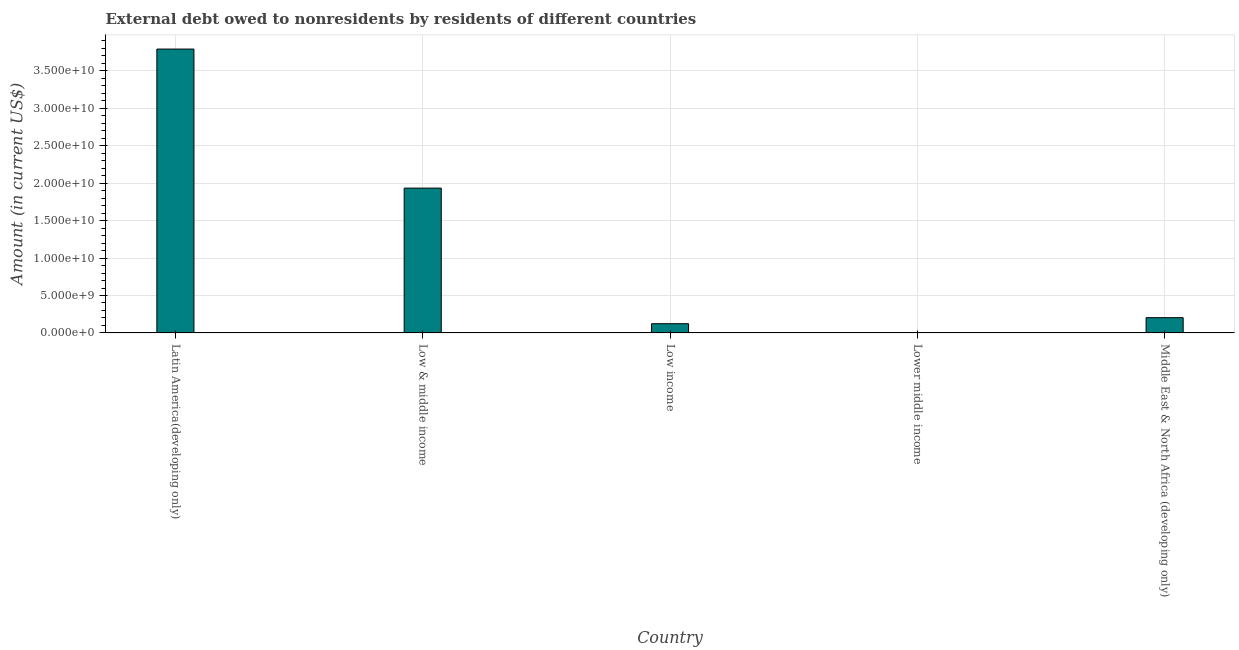Does the graph contain any zero values?
Your answer should be very brief. Yes. Does the graph contain grids?
Your response must be concise. Yes. What is the title of the graph?
Your response must be concise. External debt owed to nonresidents by residents of different countries. Across all countries, what is the maximum debt?
Your answer should be compact. 3.79e+1. In which country was the debt maximum?
Your response must be concise. Latin America(developing only). What is the sum of the debt?
Your response must be concise. 6.05e+1. What is the difference between the debt in Latin America(developing only) and Low & middle income?
Provide a short and direct response. 1.86e+1. What is the average debt per country?
Your answer should be very brief. 1.21e+1. What is the median debt?
Keep it short and to the point. 2.04e+09. What is the ratio of the debt in Latin America(developing only) to that in Low income?
Ensure brevity in your answer.  30.76. Is the debt in Latin America(developing only) less than that in Middle East & North Africa (developing only)?
Offer a very short reply. No. Is the difference between the debt in Latin America(developing only) and Middle East & North Africa (developing only) greater than the difference between any two countries?
Keep it short and to the point. No. What is the difference between the highest and the second highest debt?
Your answer should be very brief. 1.86e+1. Is the sum of the debt in Low & middle income and Low income greater than the maximum debt across all countries?
Your answer should be very brief. No. What is the difference between the highest and the lowest debt?
Offer a very short reply. 3.79e+1. In how many countries, is the debt greater than the average debt taken over all countries?
Make the answer very short. 2. How many bars are there?
Provide a short and direct response. 4. Are all the bars in the graph horizontal?
Keep it short and to the point. No. What is the difference between two consecutive major ticks on the Y-axis?
Provide a short and direct response. 5.00e+09. Are the values on the major ticks of Y-axis written in scientific E-notation?
Your response must be concise. Yes. What is the Amount (in current US$) of Latin America(developing only)?
Ensure brevity in your answer.  3.79e+1. What is the Amount (in current US$) of Low & middle income?
Provide a short and direct response. 1.93e+1. What is the Amount (in current US$) in Low income?
Offer a very short reply. 1.23e+09. What is the Amount (in current US$) in Middle East & North Africa (developing only)?
Provide a succinct answer. 2.04e+09. What is the difference between the Amount (in current US$) in Latin America(developing only) and Low & middle income?
Offer a very short reply. 1.86e+1. What is the difference between the Amount (in current US$) in Latin America(developing only) and Low income?
Offer a terse response. 3.67e+1. What is the difference between the Amount (in current US$) in Latin America(developing only) and Middle East & North Africa (developing only)?
Provide a short and direct response. 3.59e+1. What is the difference between the Amount (in current US$) in Low & middle income and Low income?
Give a very brief answer. 1.81e+1. What is the difference between the Amount (in current US$) in Low & middle income and Middle East & North Africa (developing only)?
Make the answer very short. 1.73e+1. What is the difference between the Amount (in current US$) in Low income and Middle East & North Africa (developing only)?
Offer a very short reply. -8.04e+08. What is the ratio of the Amount (in current US$) in Latin America(developing only) to that in Low & middle income?
Give a very brief answer. 1.96. What is the ratio of the Amount (in current US$) in Latin America(developing only) to that in Low income?
Offer a terse response. 30.76. What is the ratio of the Amount (in current US$) in Latin America(developing only) to that in Middle East & North Africa (developing only)?
Provide a short and direct response. 18.61. What is the ratio of the Amount (in current US$) in Low & middle income to that in Low income?
Make the answer very short. 15.69. What is the ratio of the Amount (in current US$) in Low & middle income to that in Middle East & North Africa (developing only)?
Your response must be concise. 9.49. What is the ratio of the Amount (in current US$) in Low income to that in Middle East & North Africa (developing only)?
Provide a short and direct response. 0.6. 